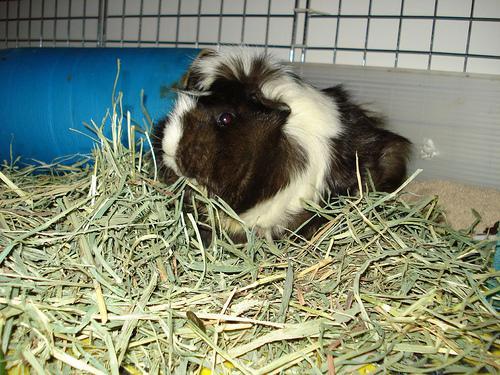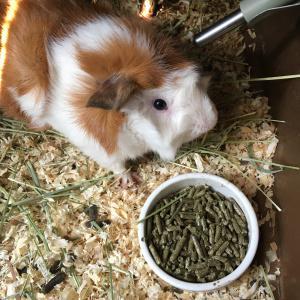The first image is the image on the left, the second image is the image on the right. For the images shown, is this caption "An image shows multiple guinea pigs around a bowl of food." true? Answer yes or no. No. 